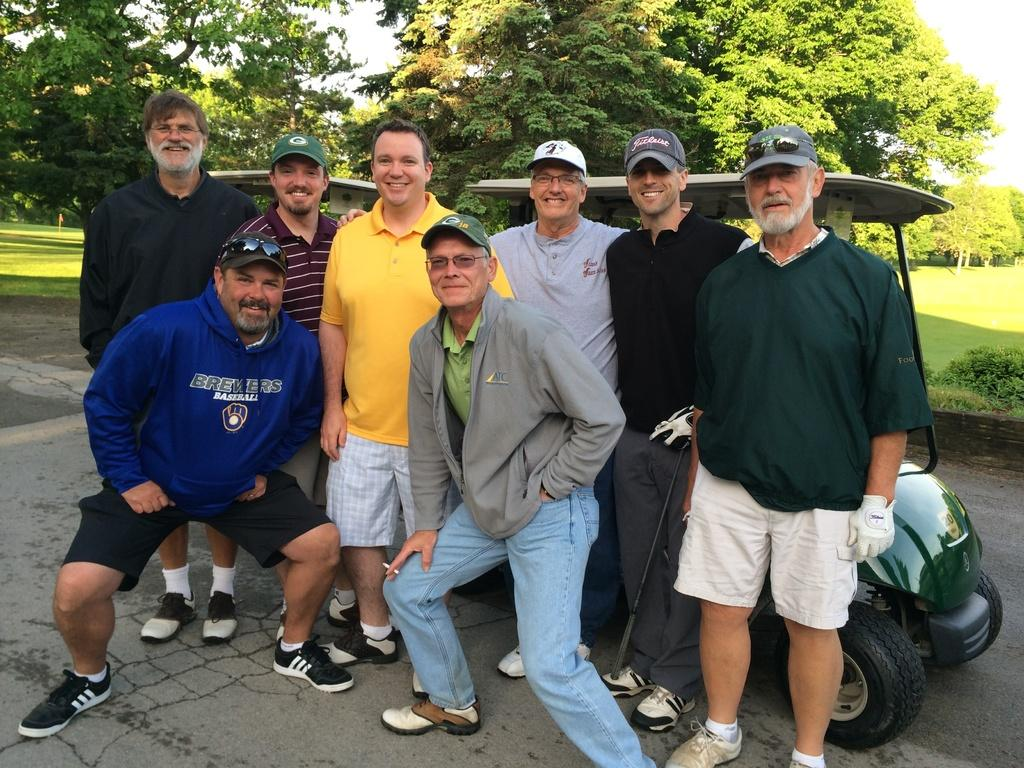What is happening with the group of people in the image? The group of people are posing for a photograph. What can be seen in the background of the image? There is a vehicle and trees in the background of the image. What type of yarn is being used to create the trees in the background? There is no yarn present in the image, and the trees are not created with yarn. 